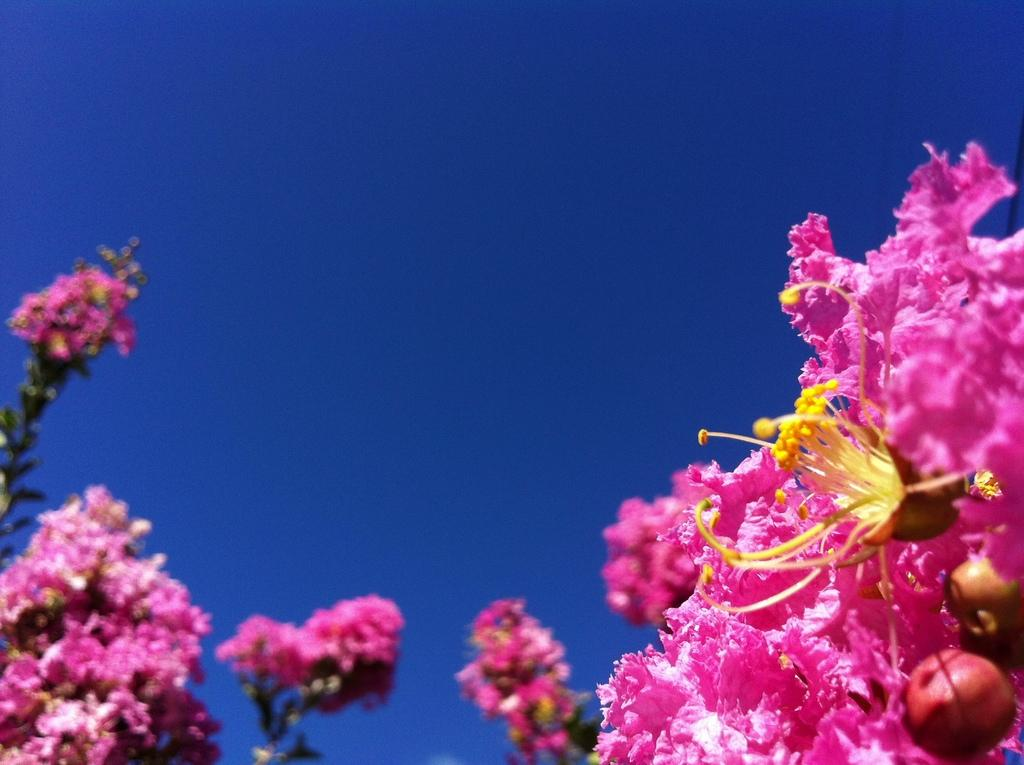What type of living organisms can be seen in the image? There are flowers in the image. What can be seen in the background of the image? The sky is visible in the background of the image. What type of bell can be heard ringing in the image? There is no bell present in the image, and therefore no sound can be heard. 